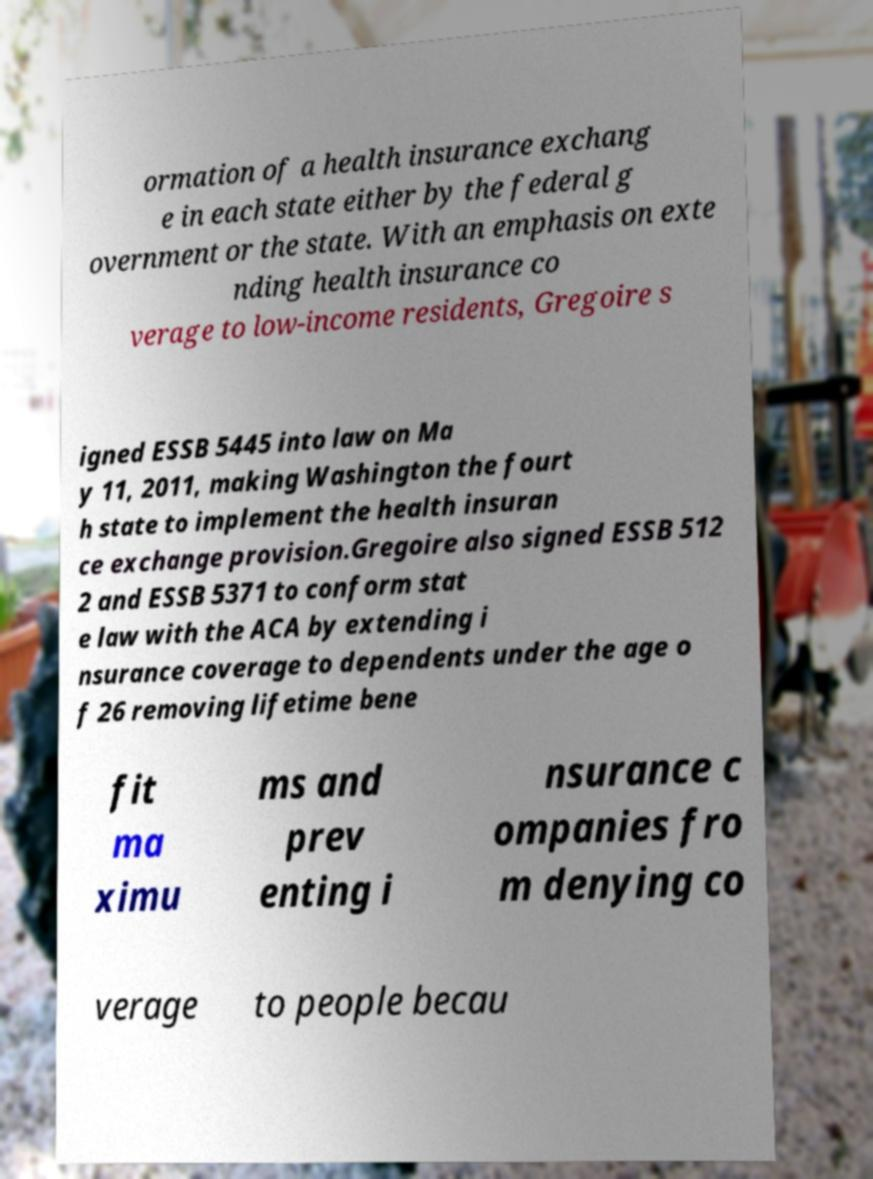Can you accurately transcribe the text from the provided image for me? ormation of a health insurance exchang e in each state either by the federal g overnment or the state. With an emphasis on exte nding health insurance co verage to low-income residents, Gregoire s igned ESSB 5445 into law on Ma y 11, 2011, making Washington the fourt h state to implement the health insuran ce exchange provision.Gregoire also signed ESSB 512 2 and ESSB 5371 to conform stat e law with the ACA by extending i nsurance coverage to dependents under the age o f 26 removing lifetime bene fit ma ximu ms and prev enting i nsurance c ompanies fro m denying co verage to people becau 